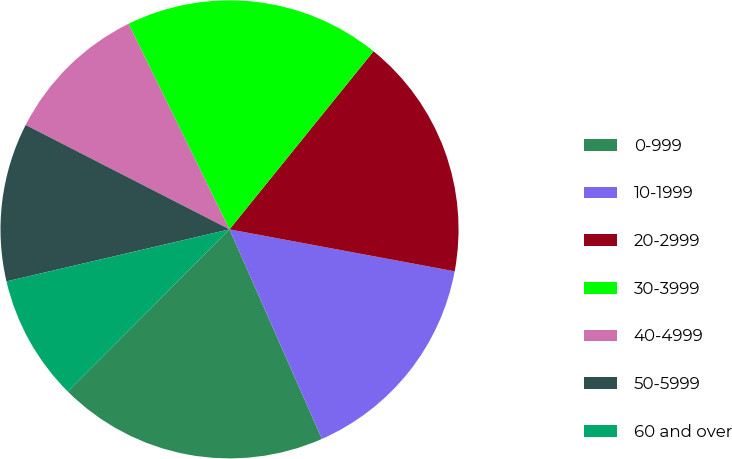Convert chart to OTSL. <chart><loc_0><loc_0><loc_500><loc_500><pie_chart><fcel>0-999<fcel>10-1999<fcel>20-2999<fcel>30-3999<fcel>40-4999<fcel>50-5999<fcel>60 and over<nl><fcel>19.08%<fcel>15.46%<fcel>17.11%<fcel>18.09%<fcel>10.2%<fcel>11.18%<fcel>8.88%<nl></chart> 